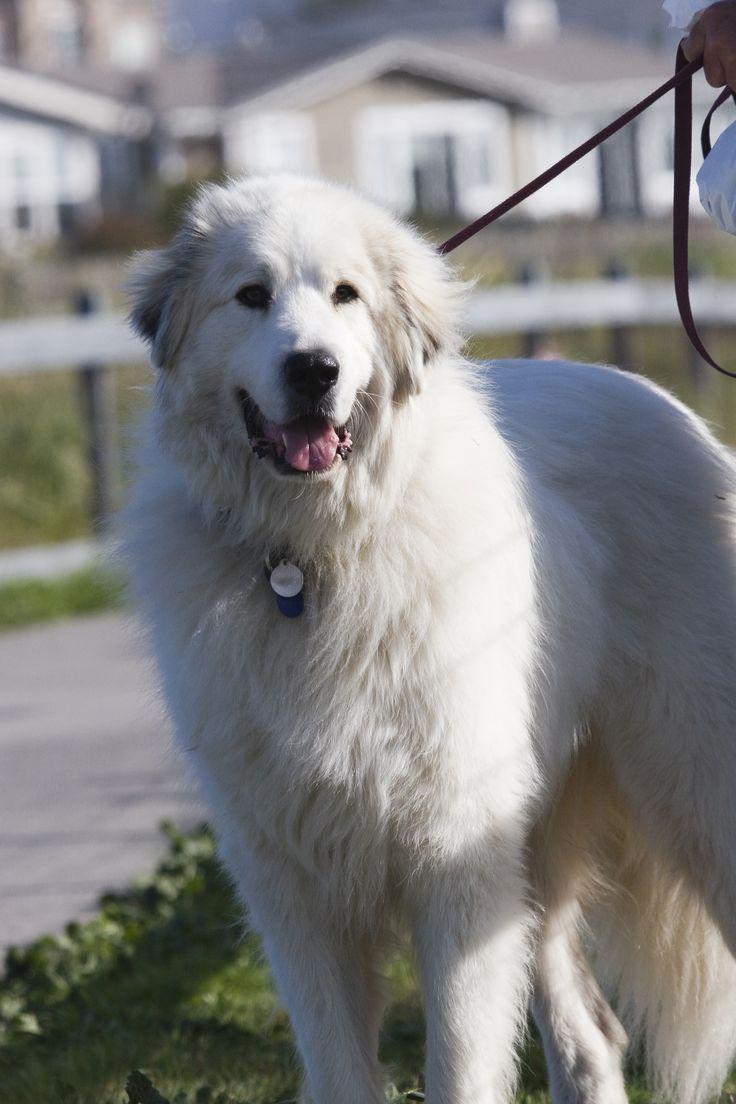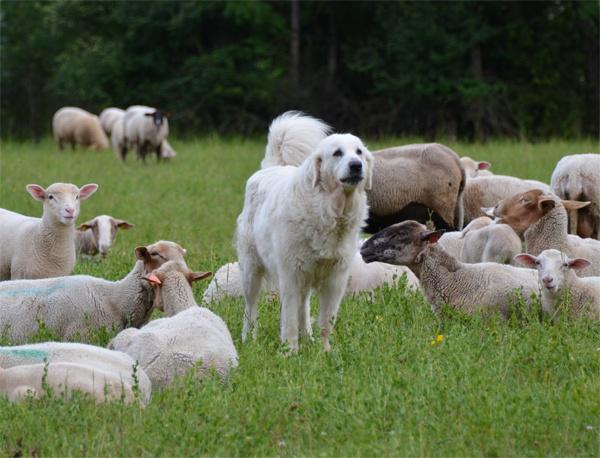The first image is the image on the left, the second image is the image on the right. Given the left and right images, does the statement "A white animal is sleeping by water in one of its states of matter." hold true? Answer yes or no. No. The first image is the image on the left, the second image is the image on the right. Analyze the images presented: Is the assertion "The dog int he image on the right is standing in a grassy area." valid? Answer yes or no. Yes. 